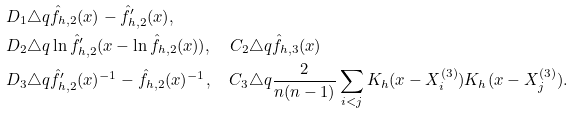Convert formula to latex. <formula><loc_0><loc_0><loc_500><loc_500>D _ { 1 } & \triangle q \hat { f } _ { h , 2 } ( x ) - \hat { f } _ { h , 2 } ^ { \prime } ( x ) , \\ D _ { 2 } & \triangle q \ln \hat { f } _ { h , 2 } ^ { \prime } ( x - \ln \hat { f } _ { h , 2 } ( x ) ) , \quad C _ { 2 } \triangle q \hat { f } _ { h , 3 } ( x ) \\ D _ { 3 } & \triangle q \hat { f } _ { h , 2 } ^ { \prime } ( x ) ^ { - 1 } - \hat { f } _ { h , 2 } ( x ) ^ { - 1 } , \quad C _ { 3 } \triangle q \frac { 2 } { n ( n - 1 ) } \sum _ { i < j } K _ { h } ( x - X _ { i } ^ { ( 3 ) } ) K _ { h } ( x - X _ { j } ^ { ( 3 ) } ) .</formula> 